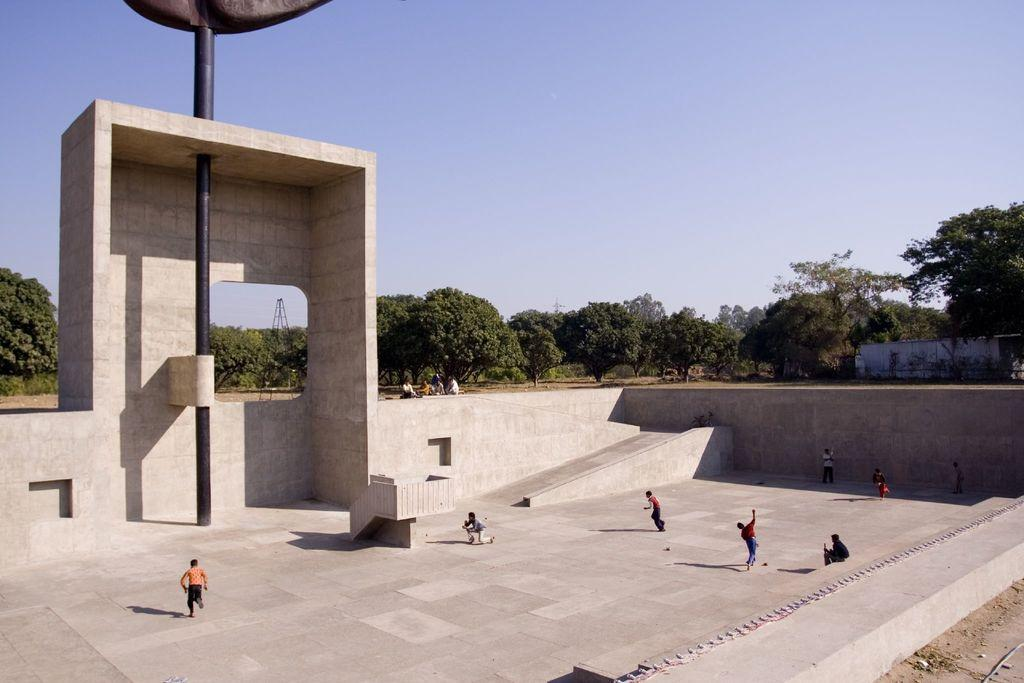How many people can be seen in the image? There are a few people in the image. What is visible beneath the people's feet? The ground is visible in the image. What architectural feature is present in the image? There is an arch in the image. What other structures can be seen in the image? There is a pole, a tower, and a wall in the image. What type of vegetation is present in the image? There are trees in the image. What part of the natural environment is visible in the image? The sky is visible in the image. What type of car can be seen driving through the arch in the image? There is no car present in the image; it only features people, an arch, a pole, a tower, a wall, trees, and the sky. 